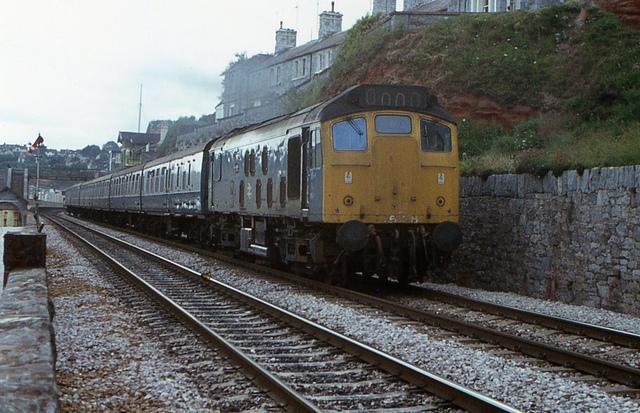Is the train moving or stopped?
Write a very short answer. Moving. Is this a train?
Short answer required. Yes. What color is the front of the train?
Short answer required. Yellow. What color is the fence?
Keep it brief. Gray. 